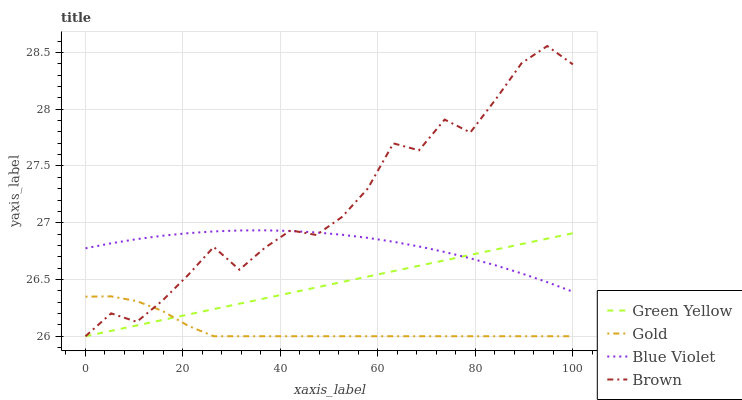Does Gold have the minimum area under the curve?
Answer yes or no. Yes. Does Brown have the maximum area under the curve?
Answer yes or no. Yes. Does Green Yellow have the minimum area under the curve?
Answer yes or no. No. Does Green Yellow have the maximum area under the curve?
Answer yes or no. No. Is Green Yellow the smoothest?
Answer yes or no. Yes. Is Brown the roughest?
Answer yes or no. Yes. Is Blue Violet the smoothest?
Answer yes or no. No. Is Blue Violet the roughest?
Answer yes or no. No. Does Blue Violet have the lowest value?
Answer yes or no. No. Does Brown have the highest value?
Answer yes or no. Yes. Does Green Yellow have the highest value?
Answer yes or no. No. Is Gold less than Blue Violet?
Answer yes or no. Yes. Is Blue Violet greater than Gold?
Answer yes or no. Yes. Does Green Yellow intersect Blue Violet?
Answer yes or no. Yes. Is Green Yellow less than Blue Violet?
Answer yes or no. No. Is Green Yellow greater than Blue Violet?
Answer yes or no. No. Does Gold intersect Blue Violet?
Answer yes or no. No. 